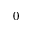<formula> <loc_0><loc_0><loc_500><loc_500>0</formula> 